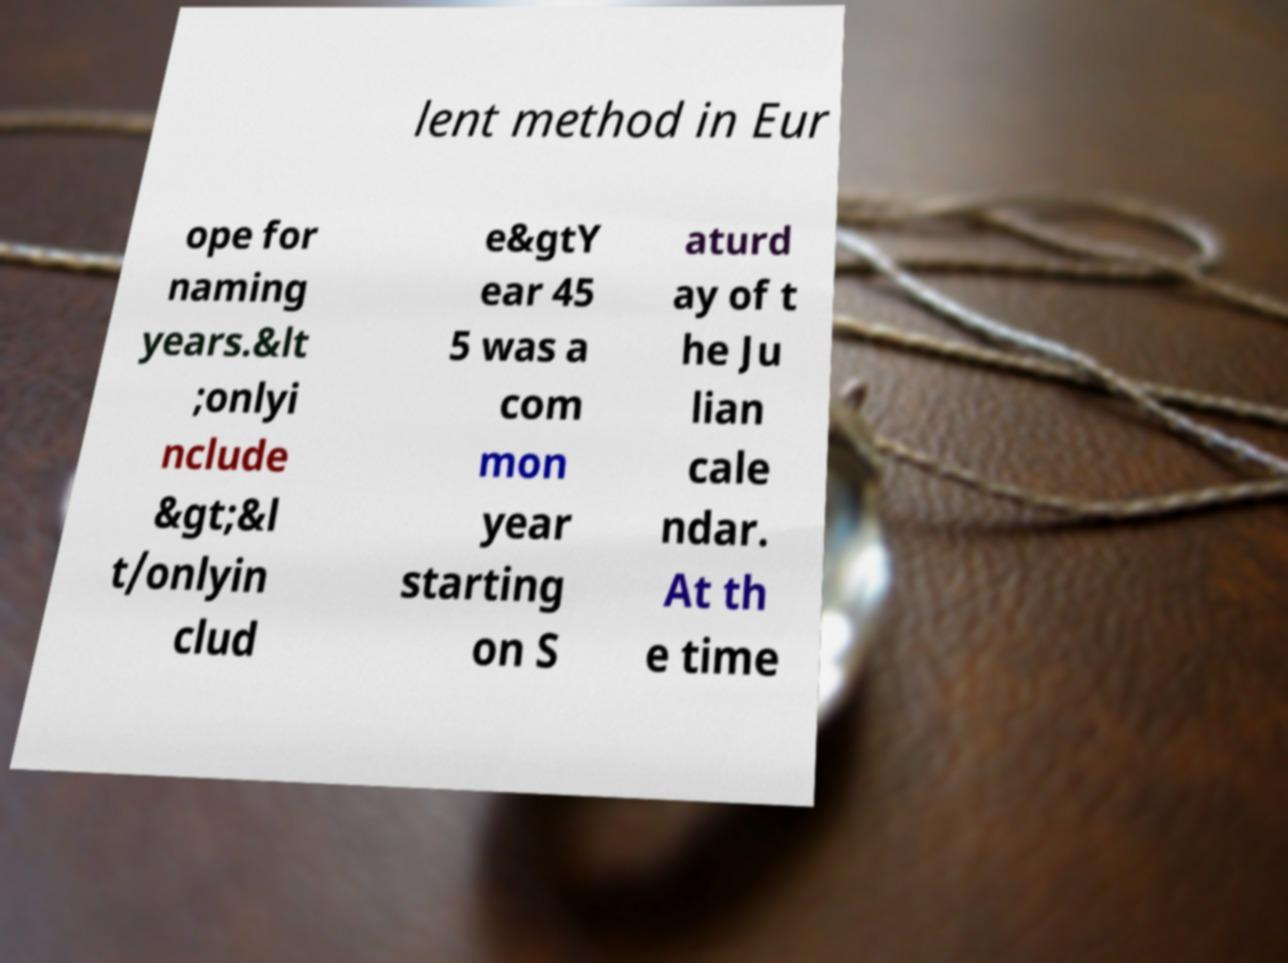Can you accurately transcribe the text from the provided image for me? lent method in Eur ope for naming years.&lt ;onlyi nclude &gt;&l t/onlyin clud e&gtY ear 45 5 was a com mon year starting on S aturd ay of t he Ju lian cale ndar. At th e time 